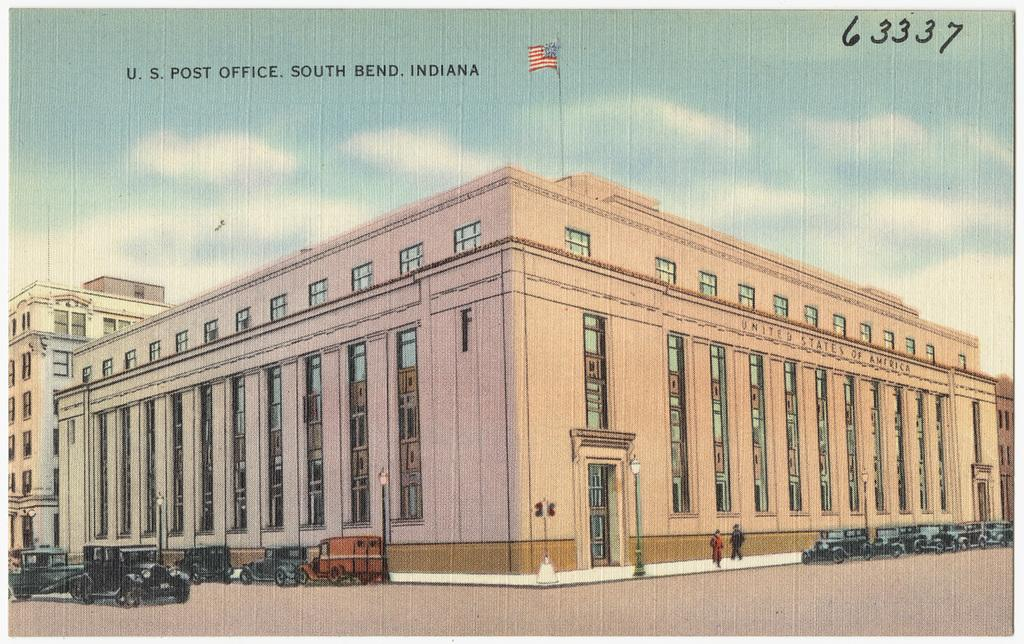What types of objects can be seen in the image? There are vehicles and buildings in the image. Can you describe any specific features of the buildings? There is a pole on one of the buildings. What is attached to the pole on the building? There is a flag on the pole. What can be seen in the sky in the image? There are clouds in the sky, and the sky is visible in the image. What type of plantation can be seen in the image? There is no plantation present in the image; it features vehicles, buildings, a pole, and a flag. How many pages are visible in the image? There are no pages present in the image. 